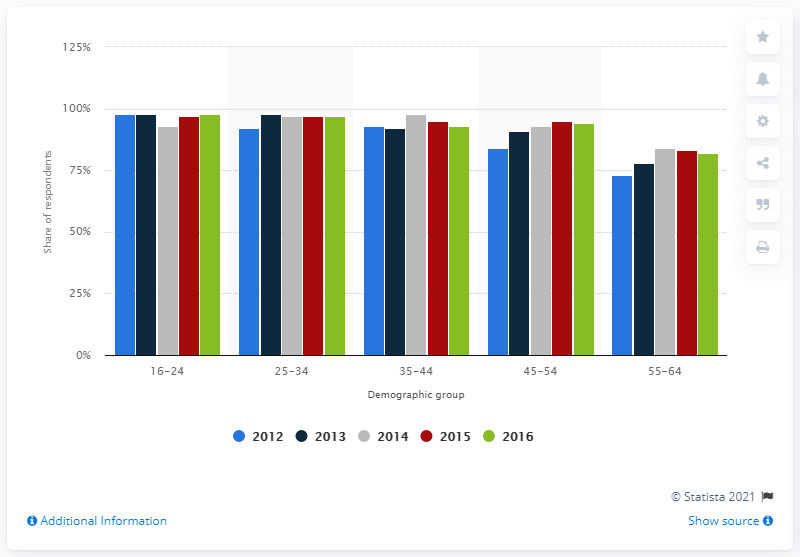Can you explain the trend in internet usage among different age groups over the years according to this chart? Certainly! The chart shows that internet usage is consistently high among the younger demographic group of 16-24 years, with a slight but not substantial variation over the years. Usage tends to decrease gradually in older age groups, although the 25-34 and 35-44 age groups also maintain relatively high usage. The 45-54 and 55-64 age groups have lower usage, but there seems to be a slight increase in their usage from 2012 to 2016. 